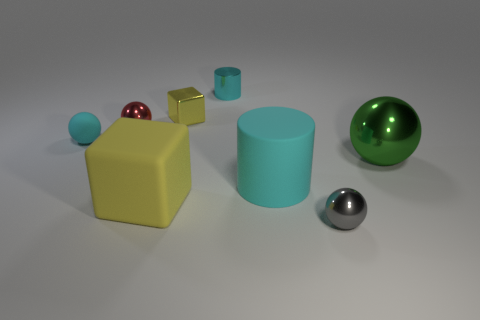How many things are in front of the yellow matte object?
Offer a very short reply. 1. Do the big yellow matte object and the cyan rubber thing that is behind the big cyan matte object have the same shape?
Offer a very short reply. No. Are there any big yellow things of the same shape as the big green object?
Keep it short and to the point. No. What shape is the yellow object that is behind the yellow block that is in front of the small rubber sphere?
Provide a short and direct response. Cube. The cyan rubber object that is in front of the green ball has what shape?
Your answer should be very brief. Cylinder. There is a tiny metallic ball that is behind the gray ball; is it the same color as the object to the right of the gray ball?
Offer a terse response. No. How many balls are right of the large cyan matte cylinder and behind the large matte cylinder?
Make the answer very short. 1. What is the size of the green object that is the same material as the red sphere?
Keep it short and to the point. Large. The red sphere has what size?
Make the answer very short. Small. What is the material of the tiny cyan ball?
Offer a very short reply. Rubber. 